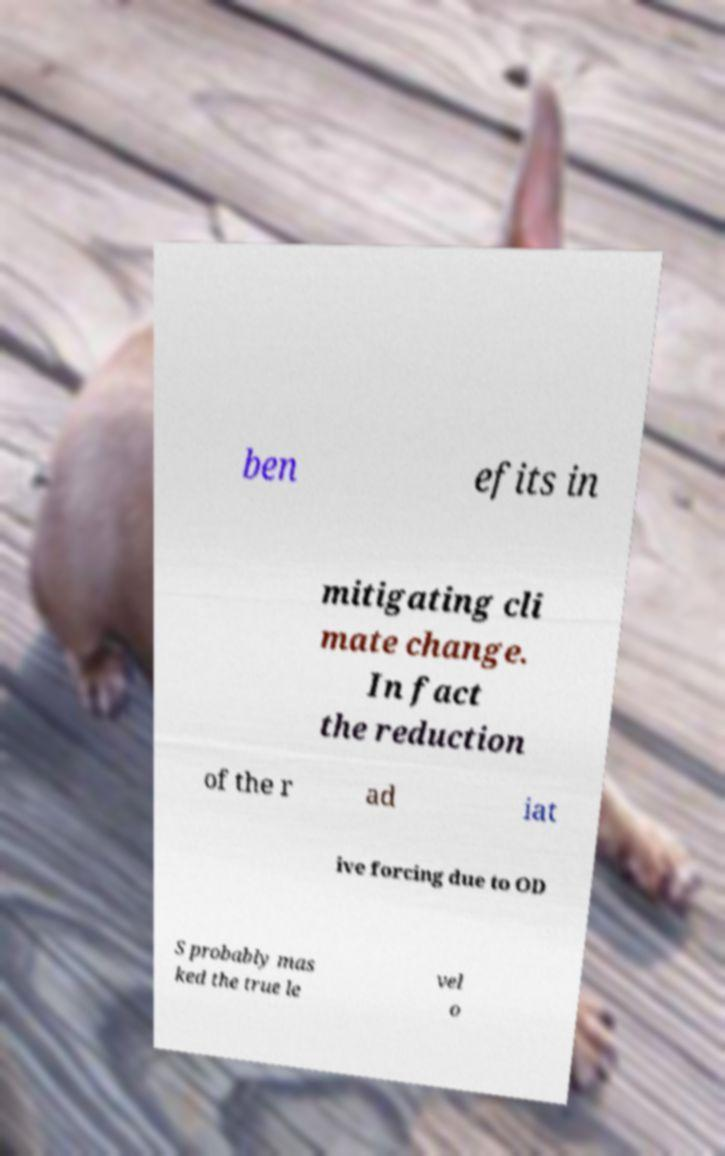There's text embedded in this image that I need extracted. Can you transcribe it verbatim? ben efits in mitigating cli mate change. In fact the reduction of the r ad iat ive forcing due to OD S probably mas ked the true le vel o 